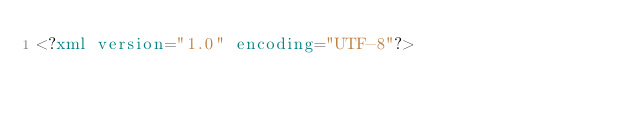<code> <loc_0><loc_0><loc_500><loc_500><_XML_><?xml version="1.0" encoding="UTF-8"?></code> 